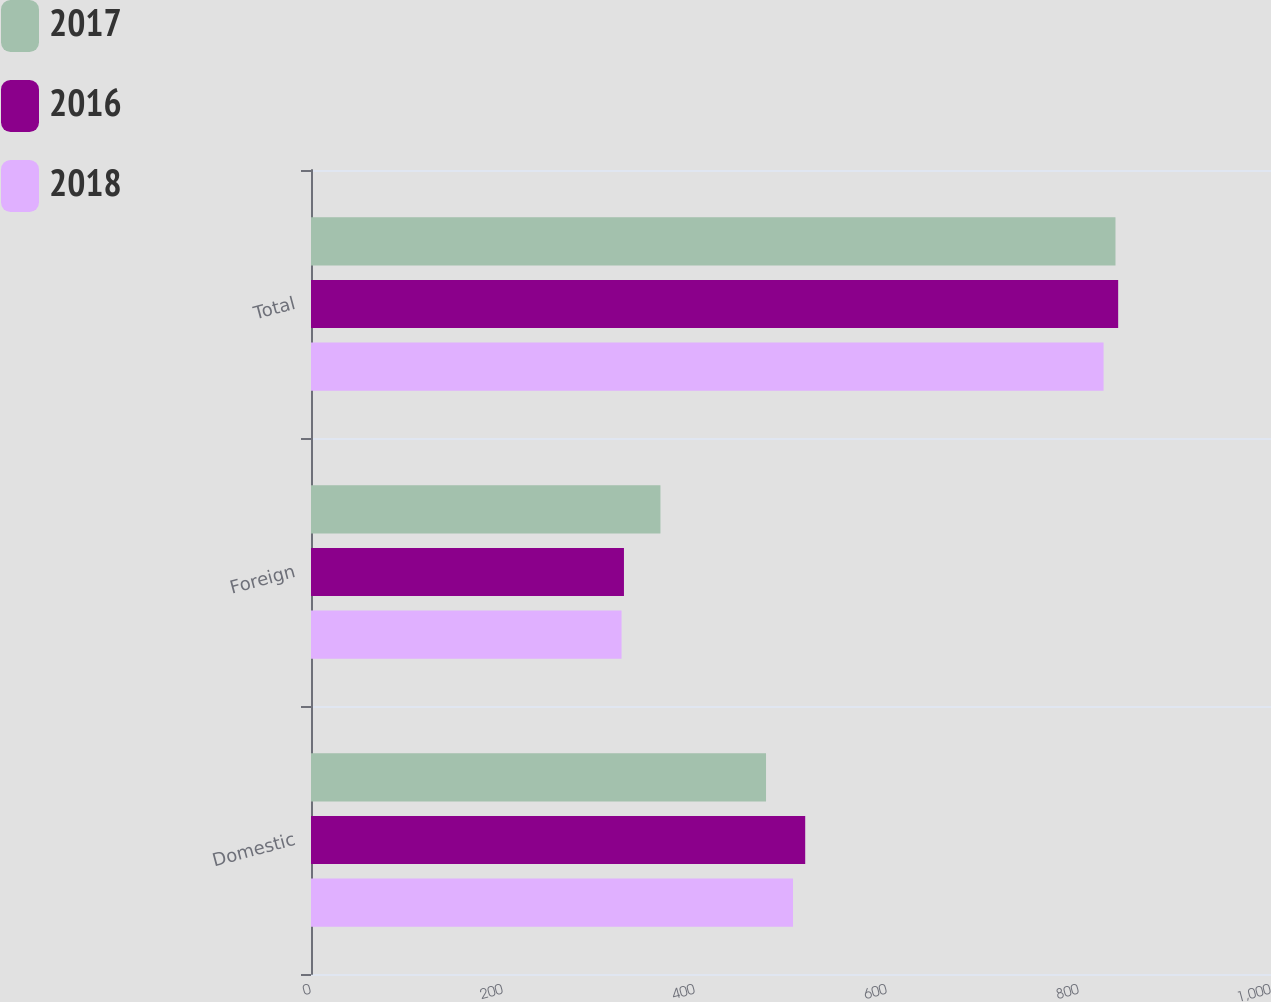Convert chart. <chart><loc_0><loc_0><loc_500><loc_500><stacked_bar_chart><ecel><fcel>Domestic<fcel>Foreign<fcel>Total<nl><fcel>2017<fcel>474<fcel>364<fcel>838<nl><fcel>2016<fcel>514.8<fcel>326<fcel>840.8<nl><fcel>2018<fcel>502.1<fcel>323.5<fcel>825.6<nl></chart> 